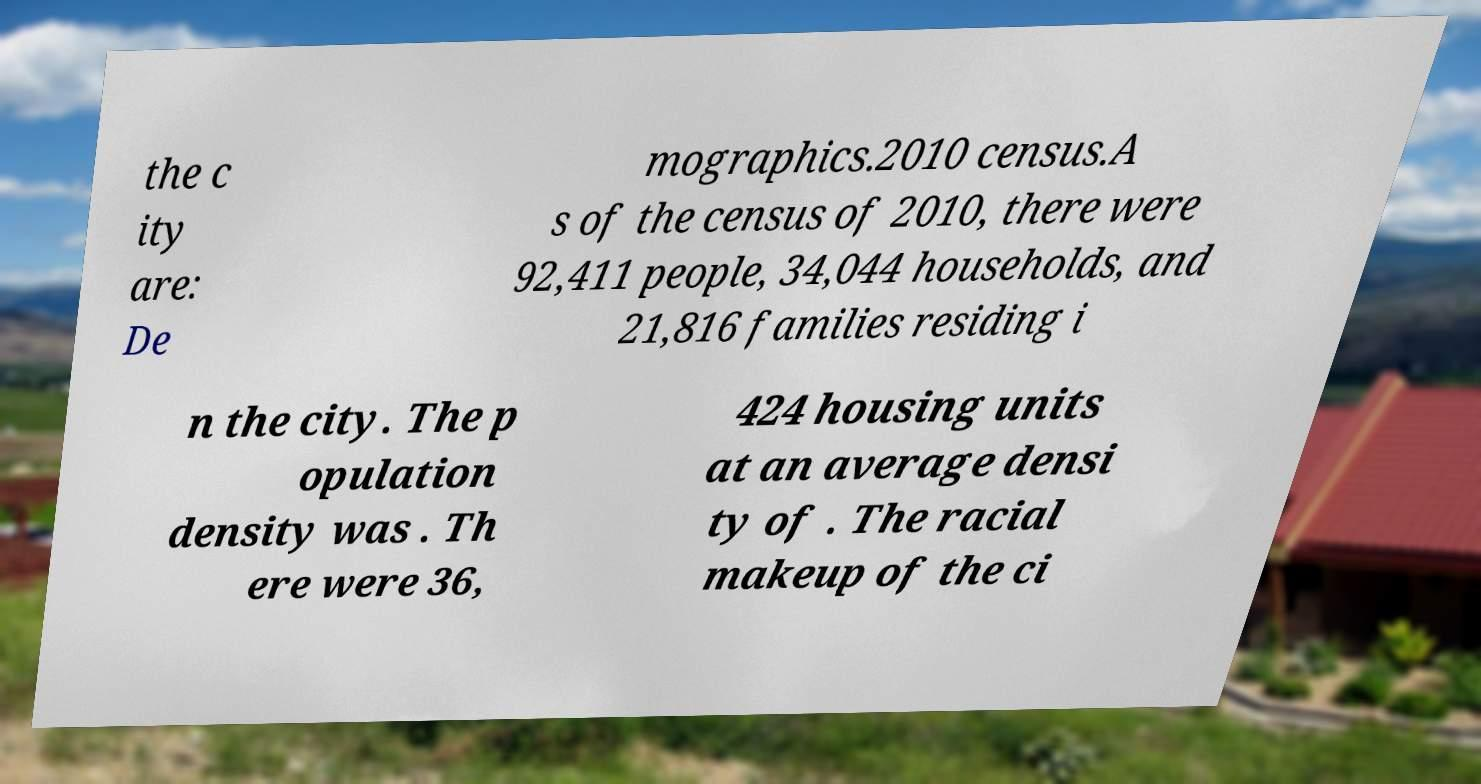Could you assist in decoding the text presented in this image and type it out clearly? the c ity are: De mographics.2010 census.A s of the census of 2010, there were 92,411 people, 34,044 households, and 21,816 families residing i n the city. The p opulation density was . Th ere were 36, 424 housing units at an average densi ty of . The racial makeup of the ci 